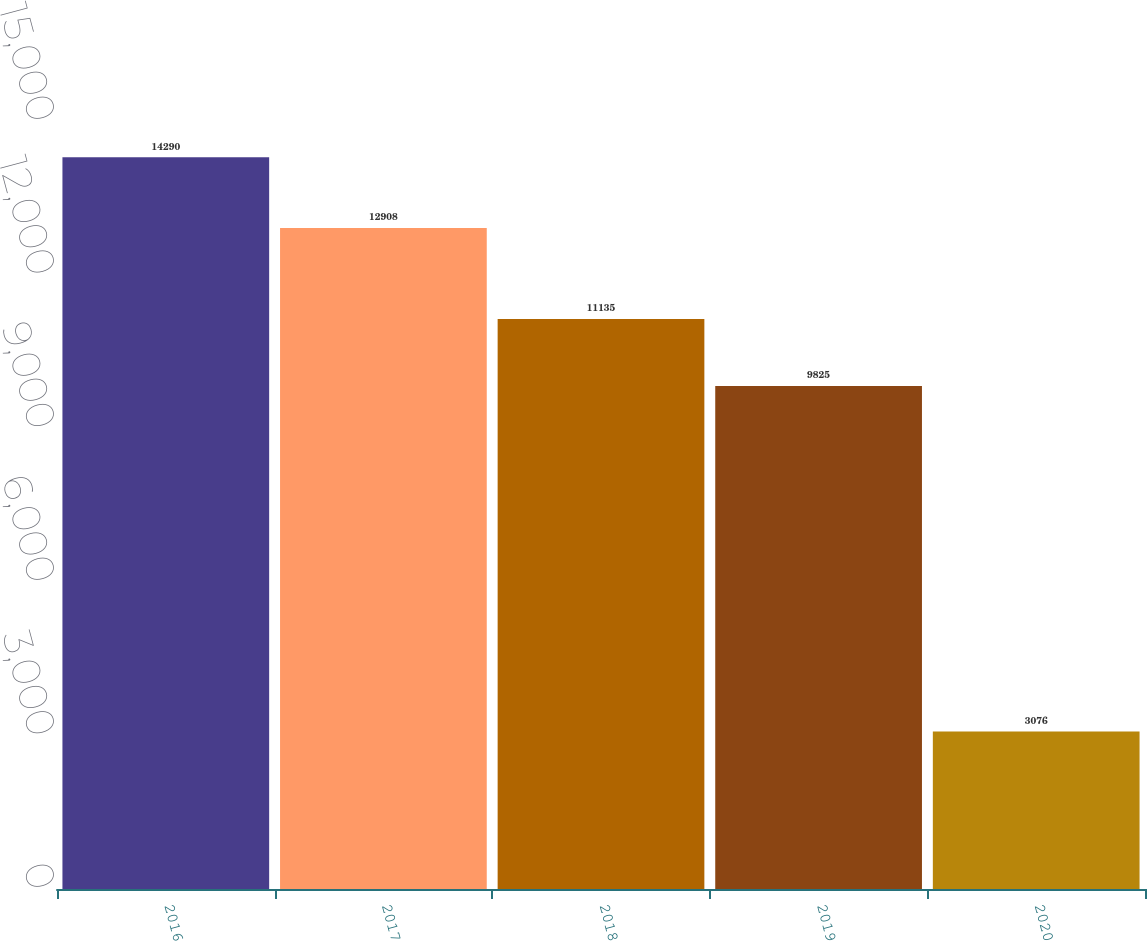Convert chart. <chart><loc_0><loc_0><loc_500><loc_500><bar_chart><fcel>2016<fcel>2017<fcel>2018<fcel>2019<fcel>2020<nl><fcel>14290<fcel>12908<fcel>11135<fcel>9825<fcel>3076<nl></chart> 